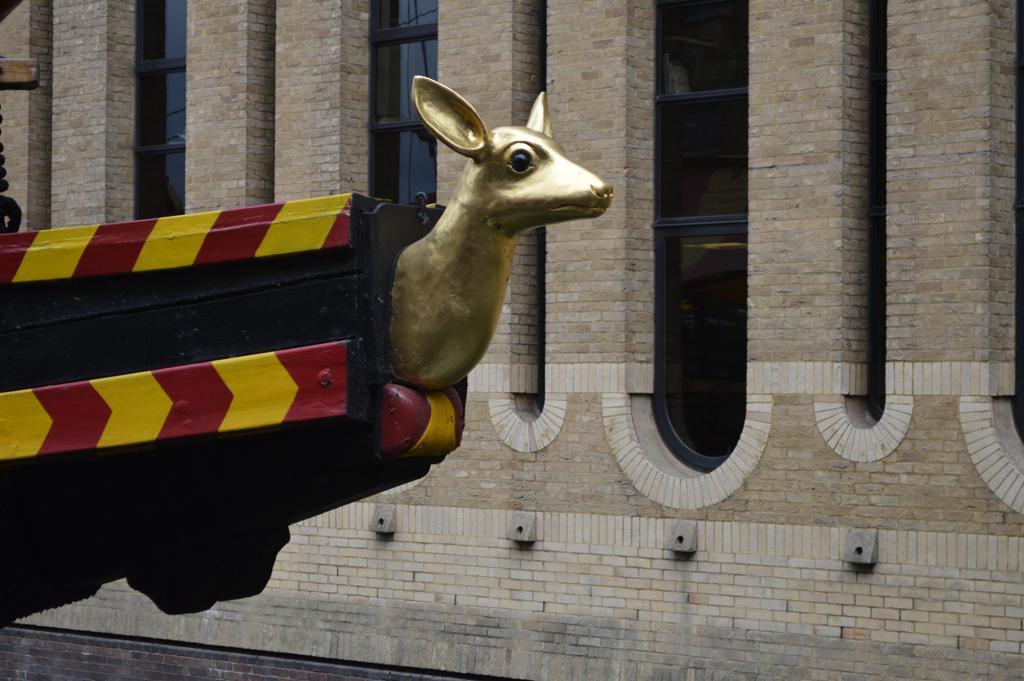In one or two sentences, can you explain what this image depicts? There is a golden color statue which is attached to an object. This object is hanged with a chain. In the background, there is a building. Which is having glass windows. 